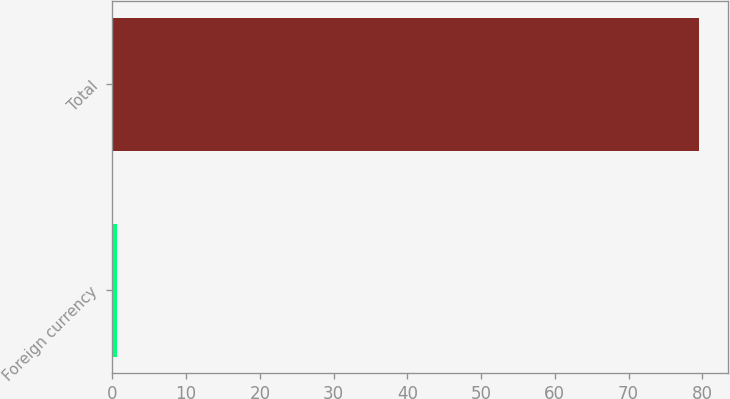<chart> <loc_0><loc_0><loc_500><loc_500><bar_chart><fcel>Foreign currency<fcel>Total<nl><fcel>0.6<fcel>79.5<nl></chart> 